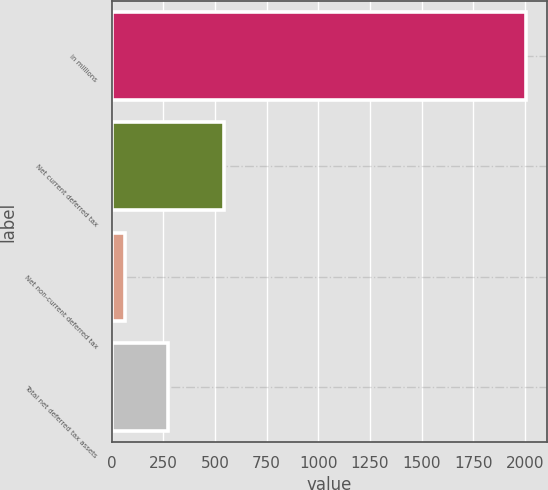Convert chart. <chart><loc_0><loc_0><loc_500><loc_500><bar_chart><fcel>in millions<fcel>Net current deferred tax<fcel>Net non-current deferred tax<fcel>Total net deferred tax assets<nl><fcel>2007<fcel>542<fcel>65<fcel>273<nl></chart> 